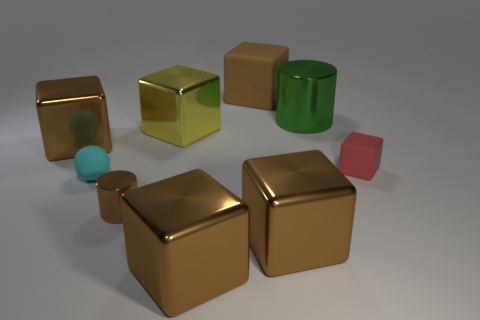Subtract all brown cubes. How many cubes are left? 2 Add 1 cyan spheres. How many objects exist? 10 Subtract all green cylinders. How many cylinders are left? 1 Subtract all cyan cylinders. How many brown blocks are left? 4 Subtract 0 blue cylinders. How many objects are left? 9 Subtract all balls. How many objects are left? 8 Subtract 1 spheres. How many spheres are left? 0 Subtract all red spheres. Subtract all cyan cylinders. How many spheres are left? 1 Subtract all yellow shiny blocks. Subtract all matte blocks. How many objects are left? 6 Add 4 large green metallic things. How many large green metallic things are left? 5 